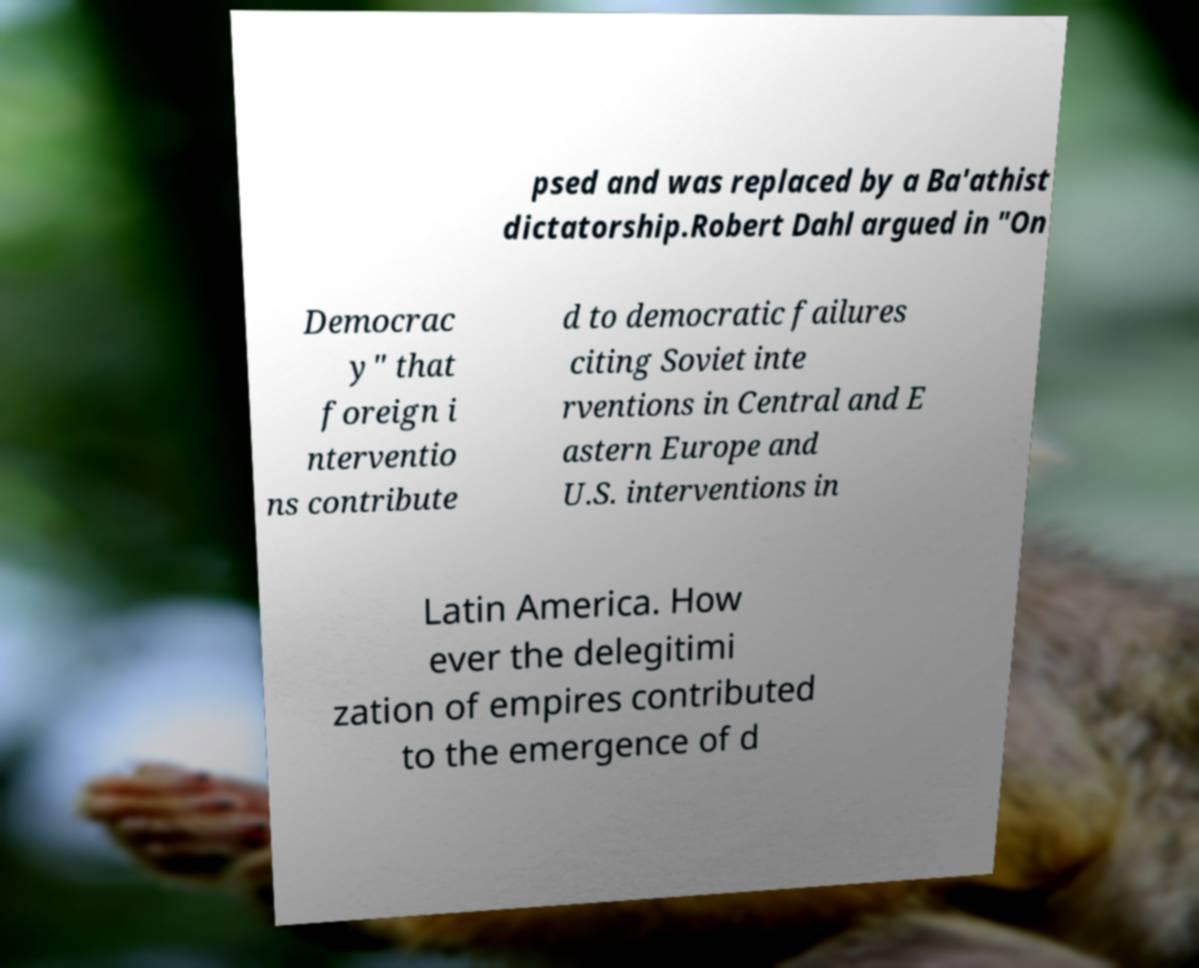What messages or text are displayed in this image? I need them in a readable, typed format. psed and was replaced by a Ba'athist dictatorship.Robert Dahl argued in "On Democrac y" that foreign i nterventio ns contribute d to democratic failures citing Soviet inte rventions in Central and E astern Europe and U.S. interventions in Latin America. How ever the delegitimi zation of empires contributed to the emergence of d 